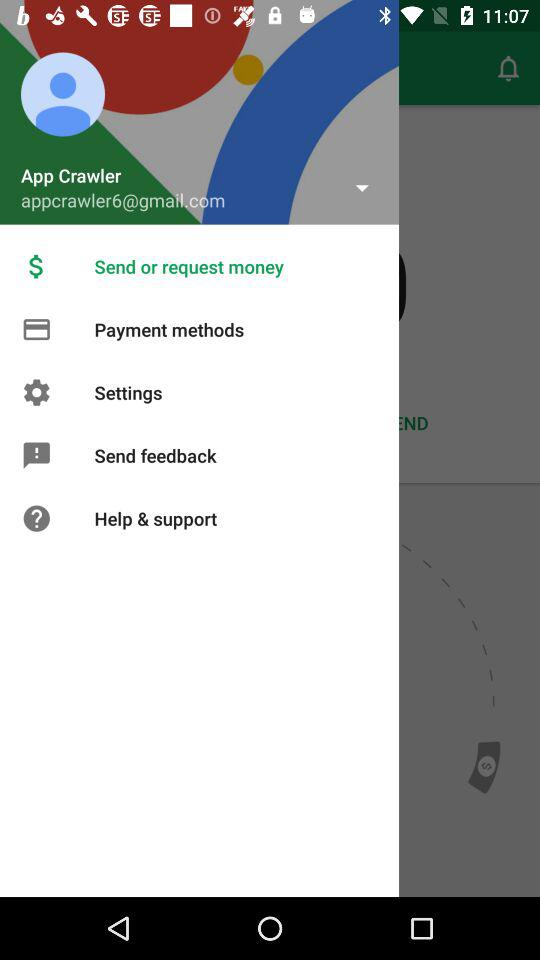What is the user name? The user name is App Crawler. 